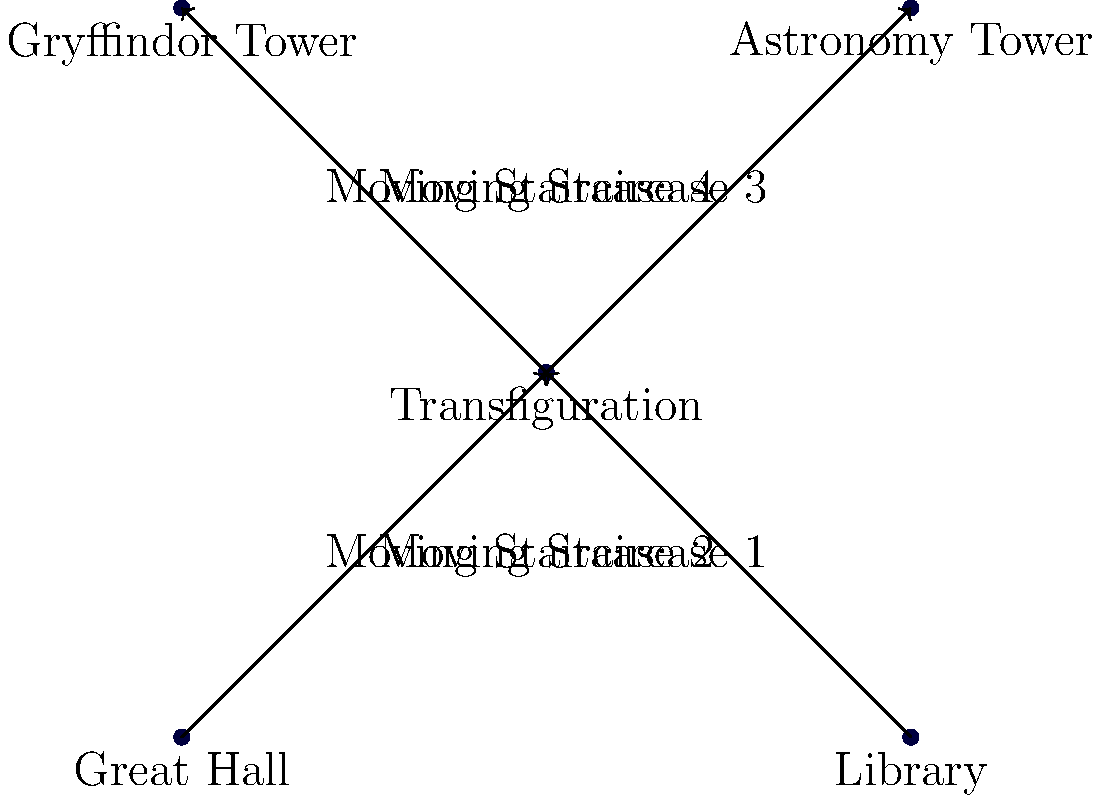In the layout of Hogwarts, the Transfiguration classroom serves as a central hub for moving staircases. If a student wants to go from the Great Hall to the Astronomy Tower using the shortest path, how many moving staircases must they use? To find the shortest path from the Great Hall to the Astronomy Tower, we need to analyze the layout:

1. The Great Hall is connected to the Transfiguration classroom by Moving Staircase 1.
2. The Transfiguration classroom is directly connected to the Astronomy Tower by Moving Staircase 4.
3. There are no direct connections between the Great Hall and the Astronomy Tower.

Therefore, the shortest path from the Great Hall to the Astronomy Tower is:

Great Hall → Moving Staircase 1 → Transfiguration classroom → Moving Staircase 4 → Astronomy Tower

This path requires the use of two moving staircases.
Answer: 2 moving staircases 